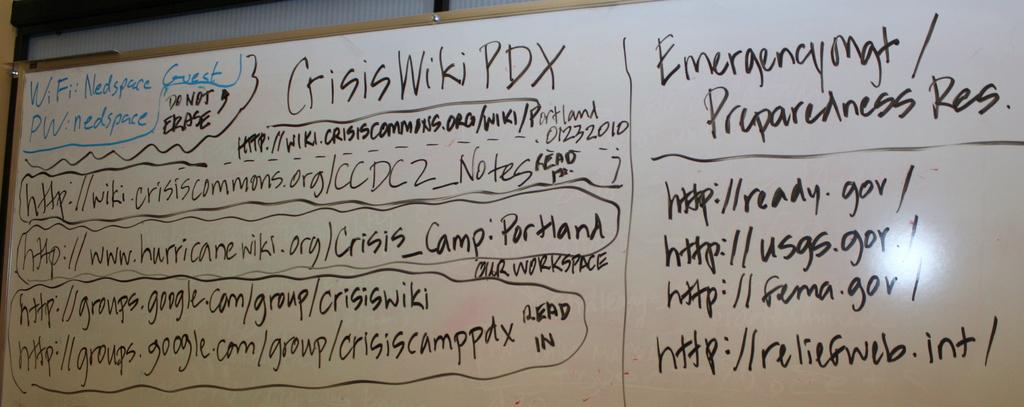Where should i go to look up emergency preparedness?
Provide a short and direct response. Http://ready.gov/. What is the last site on the list?
Offer a terse response. Http://reliefweb.int/. 